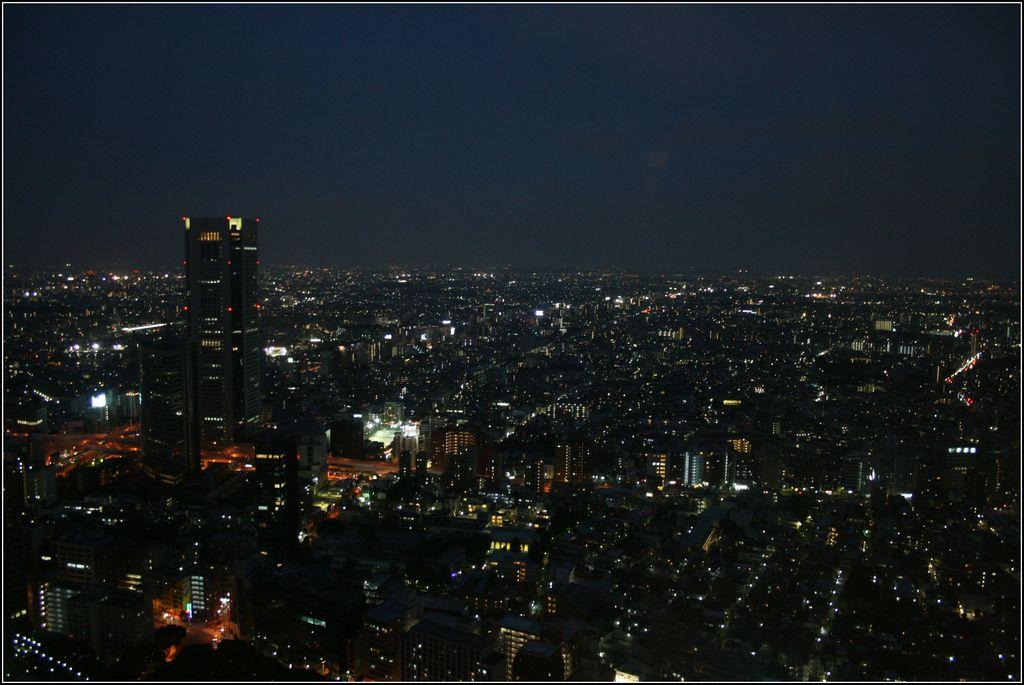Where was the image taken? The image was clicked outside the city. What can be seen in the foreground of the image? There are many buildings, lights, and skyscrapers visible in the foreground. What is visible in the background of the image? The sky is visible in the background. Is there a camp visible in the image? No, there is no camp present in the image. What type of quilt is draped over the skyscrapers in the image? There is no quilt visible in the image; it features buildings, lights, and skyscrapers without any textiles draped over them. 